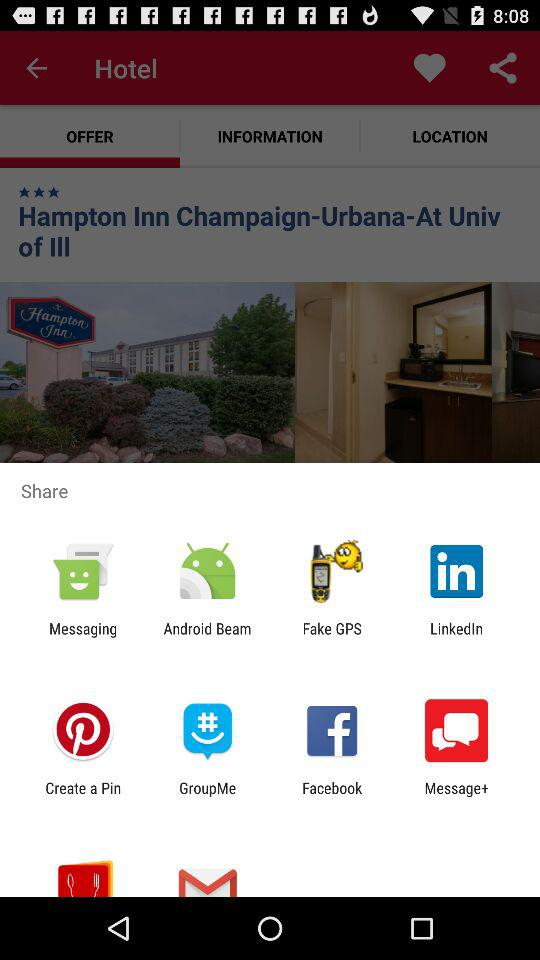How much is one room per night?
When the provided information is insufficient, respond with <no answer>. <no answer> 